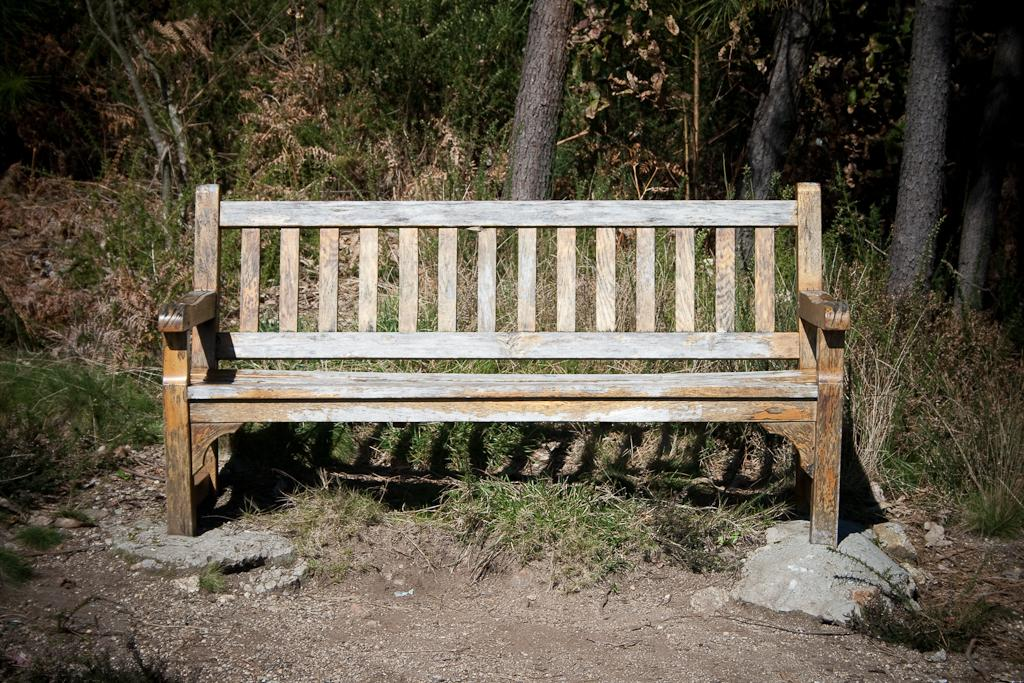What type of vegetation can be seen in the foreground of the image? There is grass in the foreground of the image. What type of seating is present in the foreground of the image? There is a bench in the foreground of the image. What type of ground is visible in the foreground of the image? Soil is present in the foreground of the image. What type of vegetation can be seen in the background of the image? There are trees in the background of the image. What type of organic material is visible in the image? Dry leaves are visible in the image. How many geese are flying over the trees in the image? There are no geese visible in the image; it only features grass, a bench, soil, trees, and dry leaves. What type of spark can be seen coming from the bench in the image? There is no spark present in the image; the bench is stationary and not producing any sparks. 